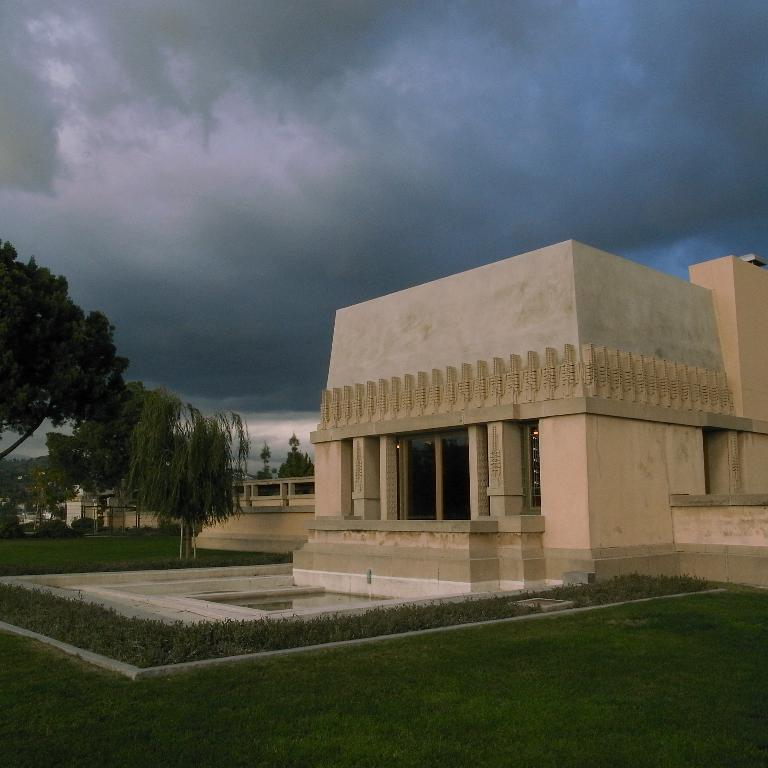What type of structures can be seen in the image? There are buildings in the image. What other natural elements are present in the image? There are trees in the image. What can be seen in the background of the image? There are clouds visible in the background of the image. Where is the vase located in the image? There is no vase present in the image. What type of dirt can be seen on the judge's robe in the image? There is no judge or dirt present in the image. 